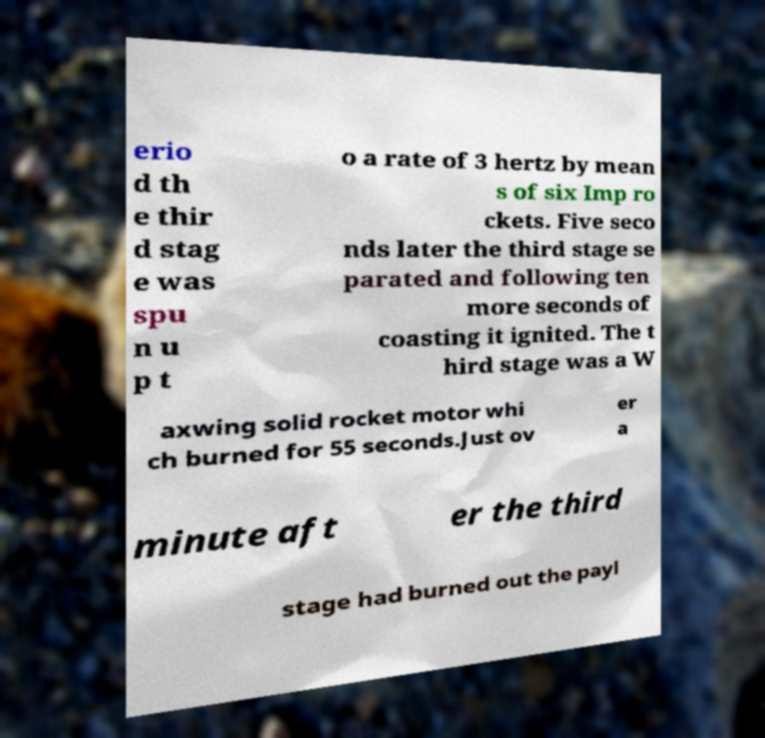Can you read and provide the text displayed in the image?This photo seems to have some interesting text. Can you extract and type it out for me? erio d th e thir d stag e was spu n u p t o a rate of 3 hertz by mean s of six Imp ro ckets. Five seco nds later the third stage se parated and following ten more seconds of coasting it ignited. The t hird stage was a W axwing solid rocket motor whi ch burned for 55 seconds.Just ov er a minute aft er the third stage had burned out the payl 